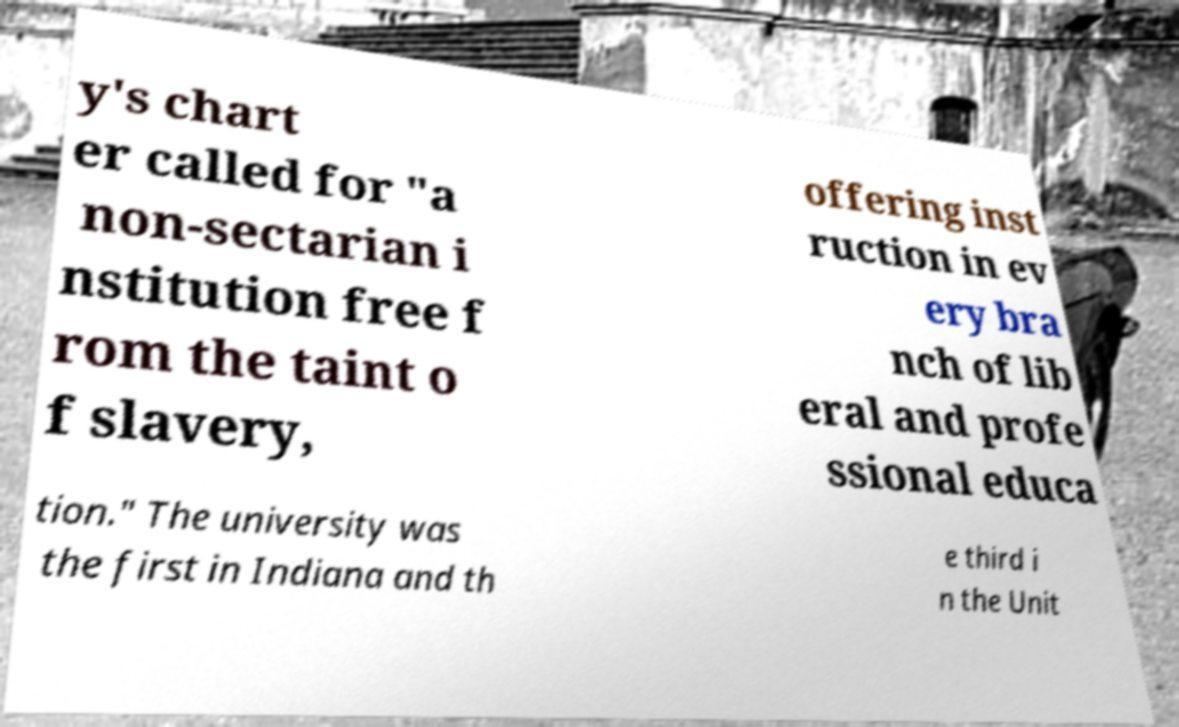Please read and relay the text visible in this image. What does it say? y's chart er called for "a non-sectarian i nstitution free f rom the taint o f slavery, offering inst ruction in ev ery bra nch of lib eral and profe ssional educa tion." The university was the first in Indiana and th e third i n the Unit 